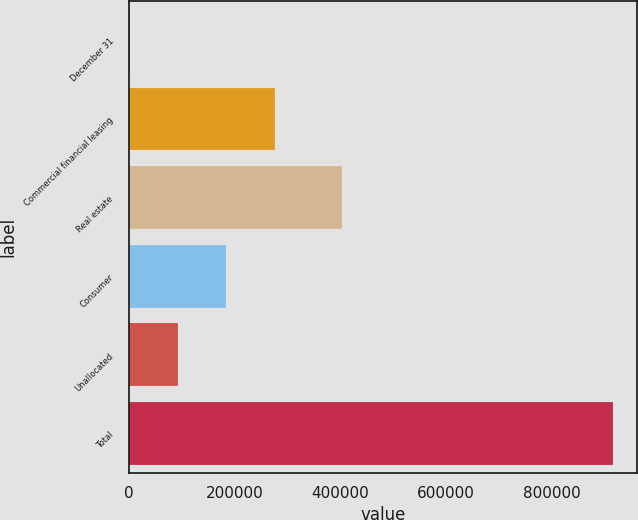Convert chart. <chart><loc_0><loc_0><loc_500><loc_500><bar_chart><fcel>December 31<fcel>Commercial financial leasing<fcel>Real estate<fcel>Consumer<fcel>Unallocated<fcel>Total<nl><fcel>2013<fcel>276412<fcel>403634<fcel>184946<fcel>93479.3<fcel>916676<nl></chart> 